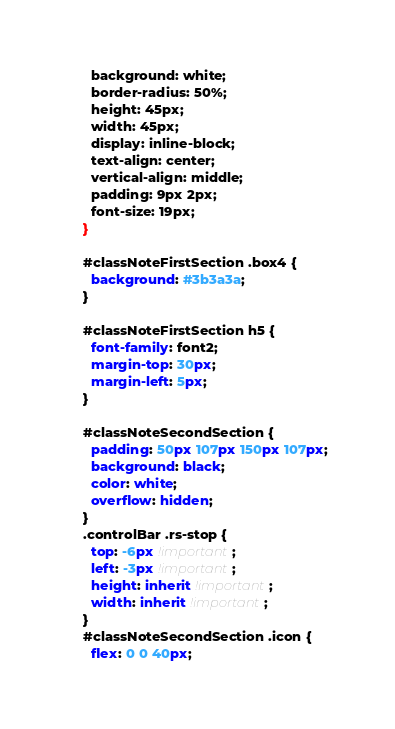Convert code to text. <code><loc_0><loc_0><loc_500><loc_500><_CSS_>  background: white;
  border-radius: 50%;
  height: 45px;
  width: 45px;
  display: inline-block;
  text-align: center;
  vertical-align: middle;
  padding: 9px 2px;
  font-size: 19px;
}

#classNoteFirstSection .box4 {
  background: #3b3a3a;
}

#classNoteFirstSection h5 {
  font-family: font2;
  margin-top: 30px;
  margin-left: 5px;
}

#classNoteSecondSection {
  padding: 50px 107px 150px 107px;
  background: black;
  color: white;
  overflow: hidden;
}
.controlBar .rs-stop {
  top: -6px !important;
  left: -3px !important;
  height: inherit !important;
  width: inherit !important;
}
#classNoteSecondSection .icon {
  flex: 0 0 40px;</code> 